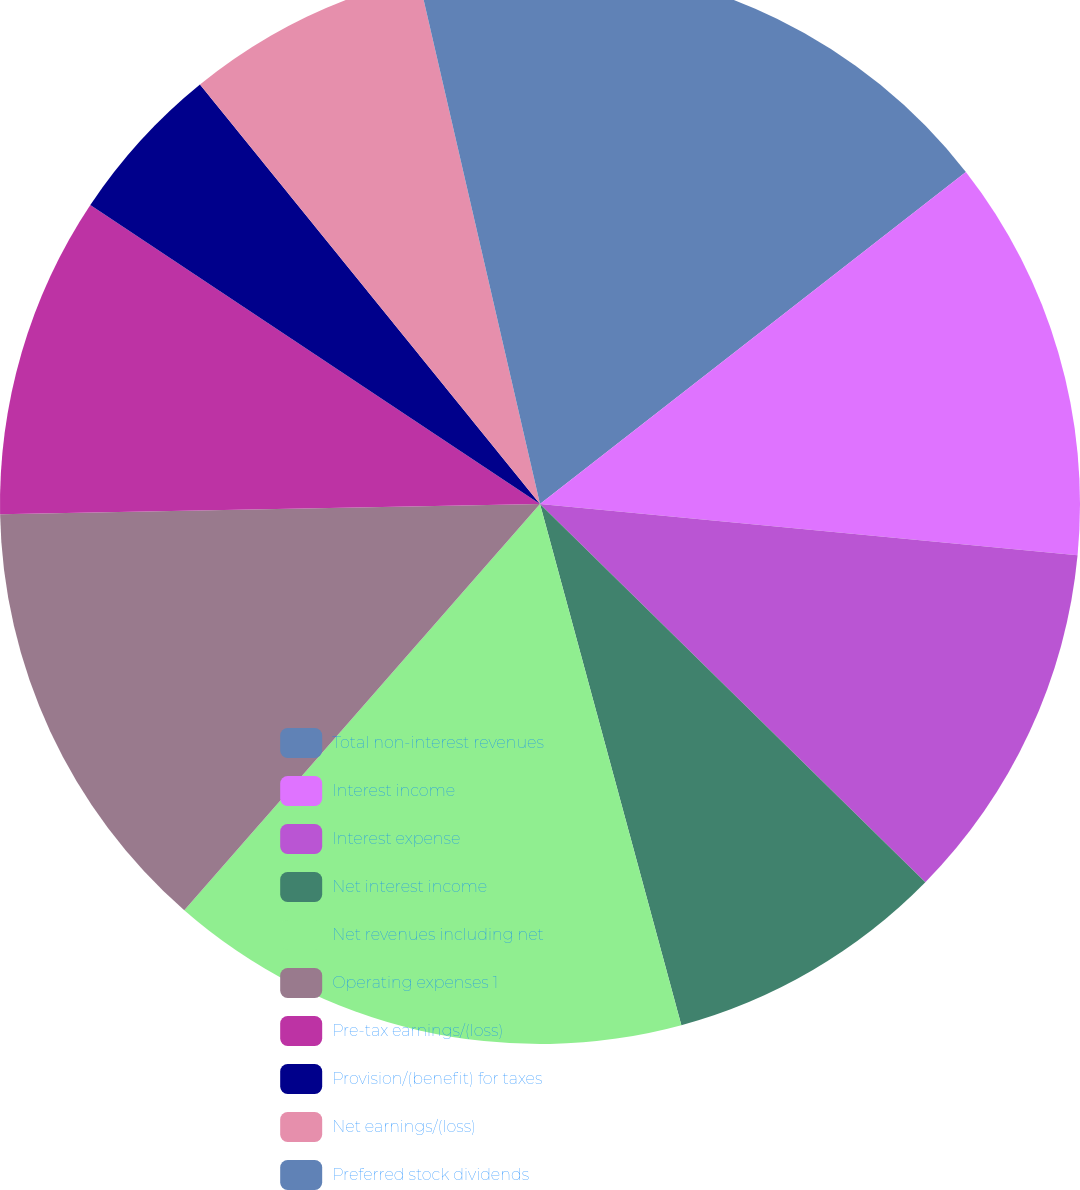Convert chart. <chart><loc_0><loc_0><loc_500><loc_500><pie_chart><fcel>Total non-interest revenues<fcel>Interest income<fcel>Interest expense<fcel>Net interest income<fcel>Net revenues including net<fcel>Operating expenses 1<fcel>Pre-tax earnings/(loss)<fcel>Provision/(benefit) for taxes<fcel>Net earnings/(loss)<fcel>Preferred stock dividends<nl><fcel>14.46%<fcel>12.05%<fcel>10.84%<fcel>8.43%<fcel>15.66%<fcel>13.25%<fcel>9.64%<fcel>4.82%<fcel>7.23%<fcel>3.61%<nl></chart> 